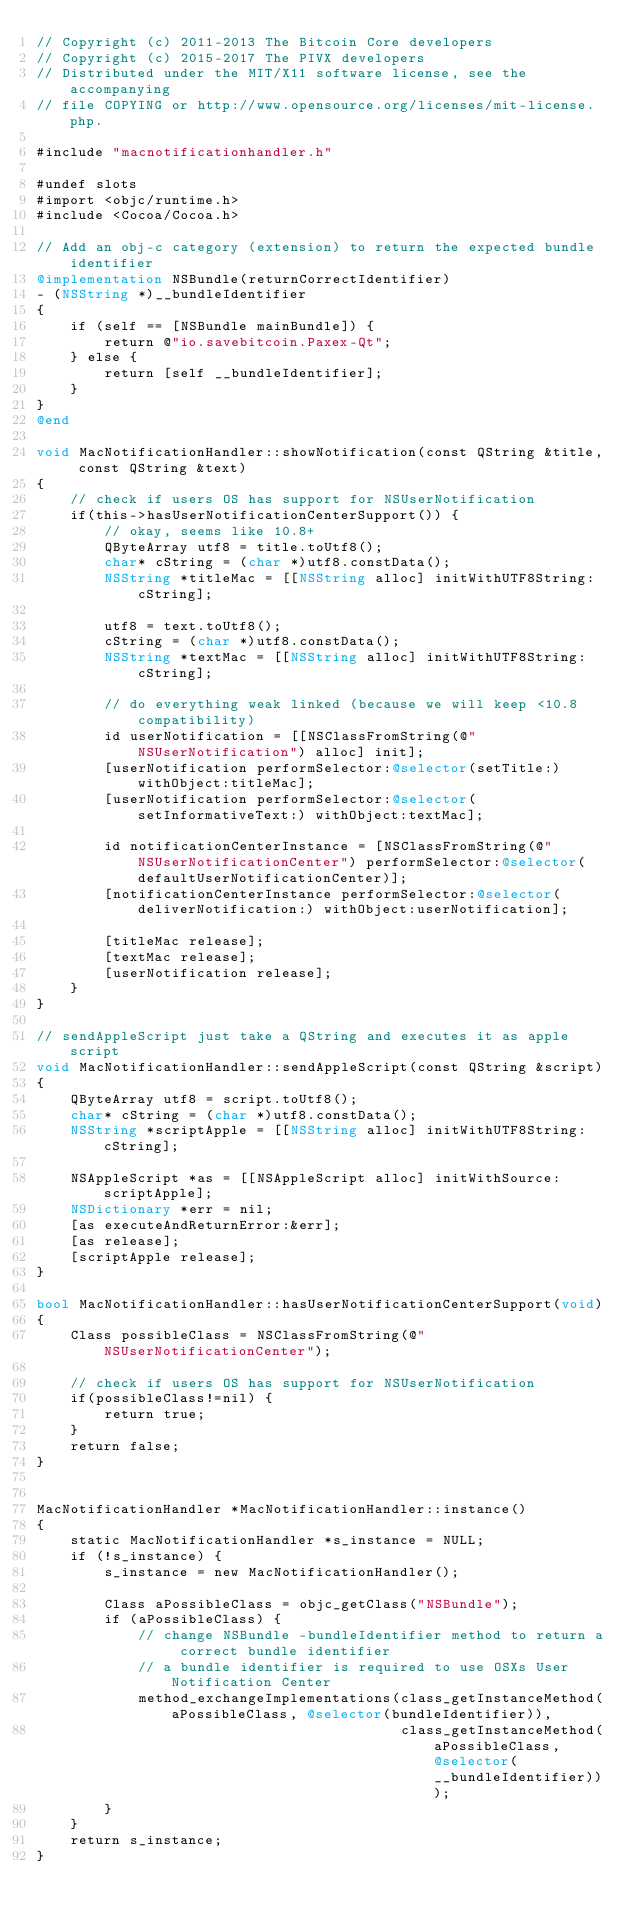Convert code to text. <code><loc_0><loc_0><loc_500><loc_500><_ObjectiveC_>// Copyright (c) 2011-2013 The Bitcoin Core developers
// Copyright (c) 2015-2017 The PIVX developers
// Distributed under the MIT/X11 software license, see the accompanying
// file COPYING or http://www.opensource.org/licenses/mit-license.php.

#include "macnotificationhandler.h"

#undef slots
#import <objc/runtime.h>
#include <Cocoa/Cocoa.h>

// Add an obj-c category (extension) to return the expected bundle identifier
@implementation NSBundle(returnCorrectIdentifier)
- (NSString *)__bundleIdentifier
{
    if (self == [NSBundle mainBundle]) {
        return @"io.savebitcoin.Paxex-Qt";
    } else {
        return [self __bundleIdentifier];
    }
}
@end

void MacNotificationHandler::showNotification(const QString &title, const QString &text)
{
    // check if users OS has support for NSUserNotification
    if(this->hasUserNotificationCenterSupport()) {
        // okay, seems like 10.8+
        QByteArray utf8 = title.toUtf8();
        char* cString = (char *)utf8.constData();
        NSString *titleMac = [[NSString alloc] initWithUTF8String:cString];

        utf8 = text.toUtf8();
        cString = (char *)utf8.constData();
        NSString *textMac = [[NSString alloc] initWithUTF8String:cString];

        // do everything weak linked (because we will keep <10.8 compatibility)
        id userNotification = [[NSClassFromString(@"NSUserNotification") alloc] init];
        [userNotification performSelector:@selector(setTitle:) withObject:titleMac];
        [userNotification performSelector:@selector(setInformativeText:) withObject:textMac];

        id notificationCenterInstance = [NSClassFromString(@"NSUserNotificationCenter") performSelector:@selector(defaultUserNotificationCenter)];
        [notificationCenterInstance performSelector:@selector(deliverNotification:) withObject:userNotification];

        [titleMac release];
        [textMac release];
        [userNotification release];
    }
}

// sendAppleScript just take a QString and executes it as apple script
void MacNotificationHandler::sendAppleScript(const QString &script)
{
    QByteArray utf8 = script.toUtf8();
    char* cString = (char *)utf8.constData();
    NSString *scriptApple = [[NSString alloc] initWithUTF8String:cString];

    NSAppleScript *as = [[NSAppleScript alloc] initWithSource:scriptApple];
    NSDictionary *err = nil;
    [as executeAndReturnError:&err];
    [as release];
    [scriptApple release];
}

bool MacNotificationHandler::hasUserNotificationCenterSupport(void)
{
    Class possibleClass = NSClassFromString(@"NSUserNotificationCenter");

    // check if users OS has support for NSUserNotification
    if(possibleClass!=nil) {
        return true;
    }
    return false;
}


MacNotificationHandler *MacNotificationHandler::instance()
{
    static MacNotificationHandler *s_instance = NULL;
    if (!s_instance) {
        s_instance = new MacNotificationHandler();
        
        Class aPossibleClass = objc_getClass("NSBundle");
        if (aPossibleClass) {
            // change NSBundle -bundleIdentifier method to return a correct bundle identifier
            // a bundle identifier is required to use OSXs User Notification Center
            method_exchangeImplementations(class_getInstanceMethod(aPossibleClass, @selector(bundleIdentifier)),
                                           class_getInstanceMethod(aPossibleClass, @selector(__bundleIdentifier)));
        }
    }
    return s_instance;
}
</code> 